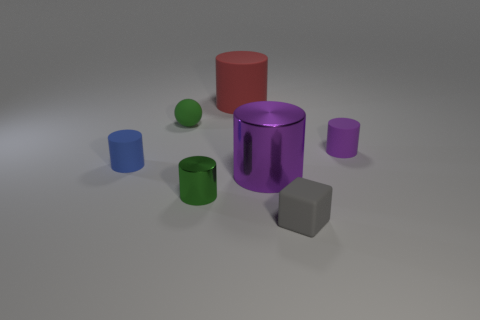Subtract all red cylinders. How many cylinders are left? 4 Subtract all blue matte cylinders. How many cylinders are left? 4 Subtract all gray cylinders. Subtract all gray balls. How many cylinders are left? 5 Add 2 tiny purple objects. How many objects exist? 9 Subtract all balls. How many objects are left? 6 Add 5 blocks. How many blocks are left? 6 Add 6 green spheres. How many green spheres exist? 7 Subtract 0 blue blocks. How many objects are left? 7 Subtract all big cyan metallic cubes. Subtract all green matte things. How many objects are left? 6 